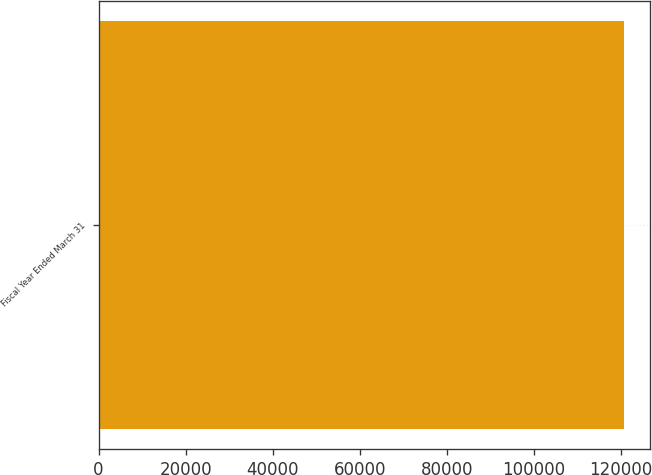<chart> <loc_0><loc_0><loc_500><loc_500><bar_chart><fcel>Fiscal Year Ended March 31<nl><fcel>120721<nl></chart> 